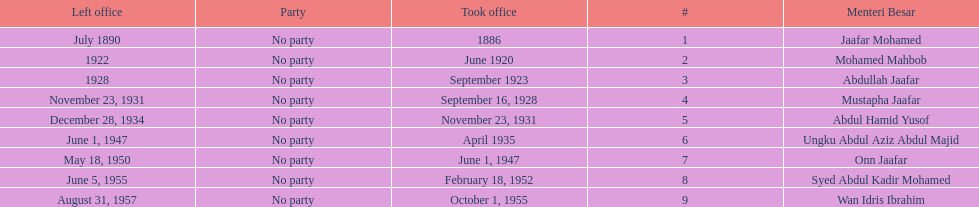What is the number of menteri besars that there have been during the pre-independence period? 9. 